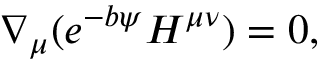Convert formula to latex. <formula><loc_0><loc_0><loc_500><loc_500>\nabla _ { \mu } ( e ^ { - b \psi } H ^ { \mu \nu } ) = 0 ,</formula> 